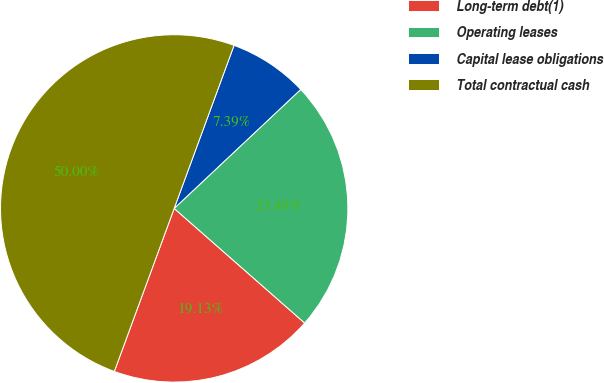Convert chart to OTSL. <chart><loc_0><loc_0><loc_500><loc_500><pie_chart><fcel>Long-term debt(1)<fcel>Operating leases<fcel>Capital lease obligations<fcel>Total contractual cash<nl><fcel>19.13%<fcel>23.48%<fcel>7.39%<fcel>50.0%<nl></chart> 